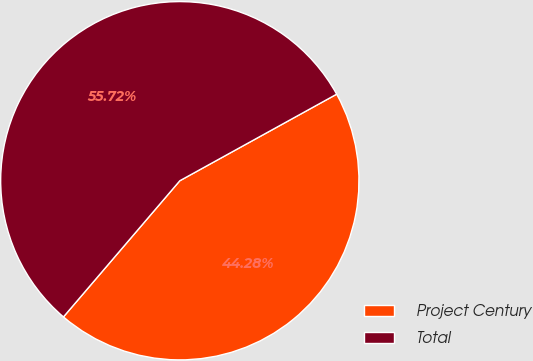Convert chart to OTSL. <chart><loc_0><loc_0><loc_500><loc_500><pie_chart><fcel>Project Century<fcel>Total<nl><fcel>44.28%<fcel>55.72%<nl></chart> 